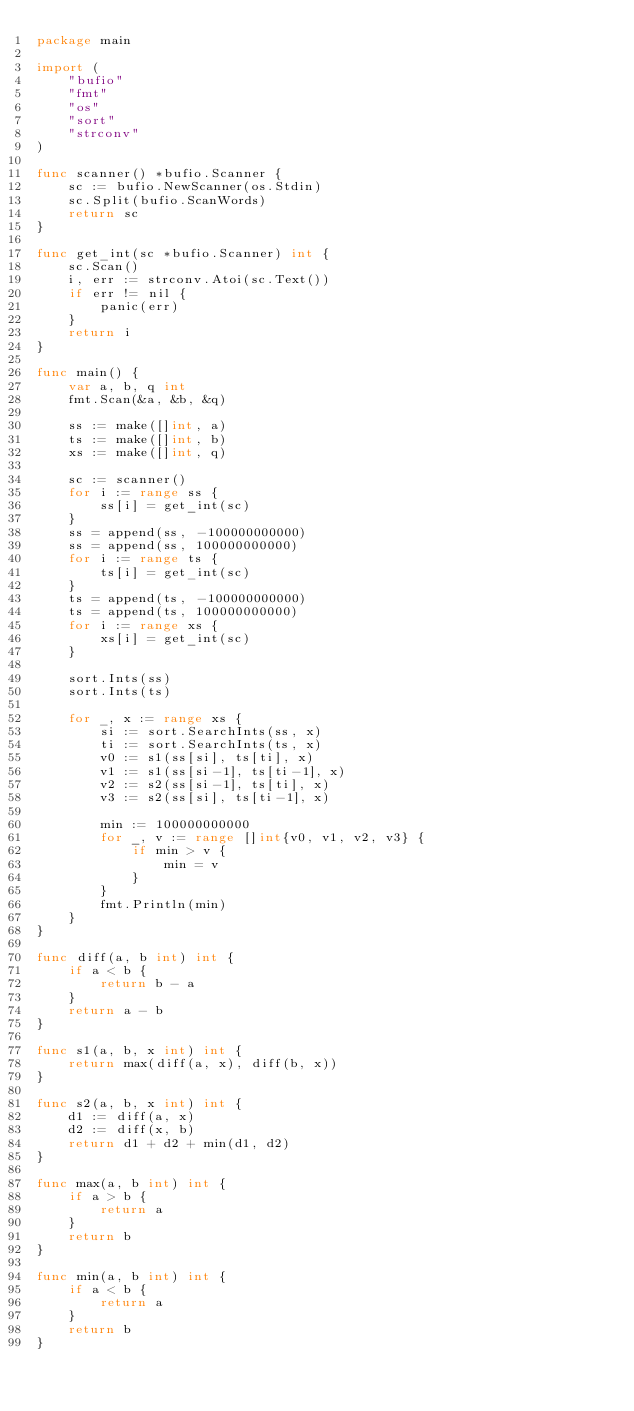<code> <loc_0><loc_0><loc_500><loc_500><_Go_>package main

import (
	"bufio"
	"fmt"
	"os"
	"sort"
	"strconv"
)

func scanner() *bufio.Scanner {
	sc := bufio.NewScanner(os.Stdin)
	sc.Split(bufio.ScanWords)
	return sc
}

func get_int(sc *bufio.Scanner) int {
	sc.Scan()
	i, err := strconv.Atoi(sc.Text())
	if err != nil {
		panic(err)
	}
	return i
}

func main() {
	var a, b, q int
	fmt.Scan(&a, &b, &q)

	ss := make([]int, a)
	ts := make([]int, b)
	xs := make([]int, q)

	sc := scanner()
	for i := range ss {
		ss[i] = get_int(sc)
	}
	ss = append(ss, -100000000000)
	ss = append(ss, 100000000000)
	for i := range ts {
		ts[i] = get_int(sc)
	}
	ts = append(ts, -100000000000)
	ts = append(ts, 100000000000)
	for i := range xs {
		xs[i] = get_int(sc)
	}

	sort.Ints(ss)
	sort.Ints(ts)

	for _, x := range xs {
		si := sort.SearchInts(ss, x)
		ti := sort.SearchInts(ts, x)
		v0 := s1(ss[si], ts[ti], x)
		v1 := s1(ss[si-1], ts[ti-1], x)
		v2 := s2(ss[si-1], ts[ti], x)
		v3 := s2(ss[si], ts[ti-1], x)

		min := 100000000000
		for _, v := range []int{v0, v1, v2, v3} {
			if min > v {
				min = v
			}
		}
		fmt.Println(min)
	}
}

func diff(a, b int) int {
	if a < b {
		return b - a
	}
	return a - b
}

func s1(a, b, x int) int {
	return max(diff(a, x), diff(b, x))
}

func s2(a, b, x int) int {
	d1 := diff(a, x)
	d2 := diff(x, b)
	return d1 + d2 + min(d1, d2)
}

func max(a, b int) int {
	if a > b {
		return a
	}
	return b
}

func min(a, b int) int {
	if a < b {
		return a
	}
	return b
}
</code> 